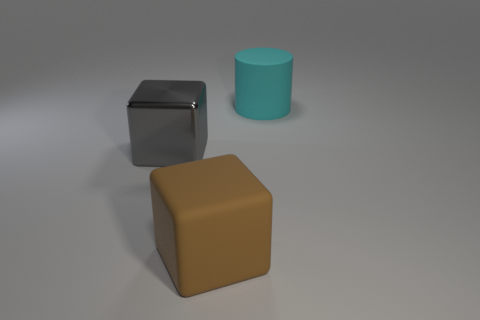Does the cyan matte object have the same shape as the gray object?
Offer a terse response. No. How many objects are either large cubes that are behind the big brown rubber cube or large red matte objects?
Make the answer very short. 1. Is there another big object of the same shape as the big gray shiny object?
Give a very brief answer. Yes. Are there an equal number of big gray blocks behind the large cylinder and large gray cubes?
Make the answer very short. No. What number of brown things are the same size as the matte cylinder?
Offer a terse response. 1. What number of big brown matte blocks are behind the cyan rubber cylinder?
Offer a very short reply. 0. There is a thing that is to the left of the large rubber thing that is left of the cyan cylinder; what is its material?
Your response must be concise. Metal. What size is the cube that is the same material as the cylinder?
Offer a very short reply. Large. Are there any other things that are the same color as the rubber cube?
Offer a very short reply. No. There is a large matte object left of the cylinder; what is its color?
Offer a terse response. Brown. 